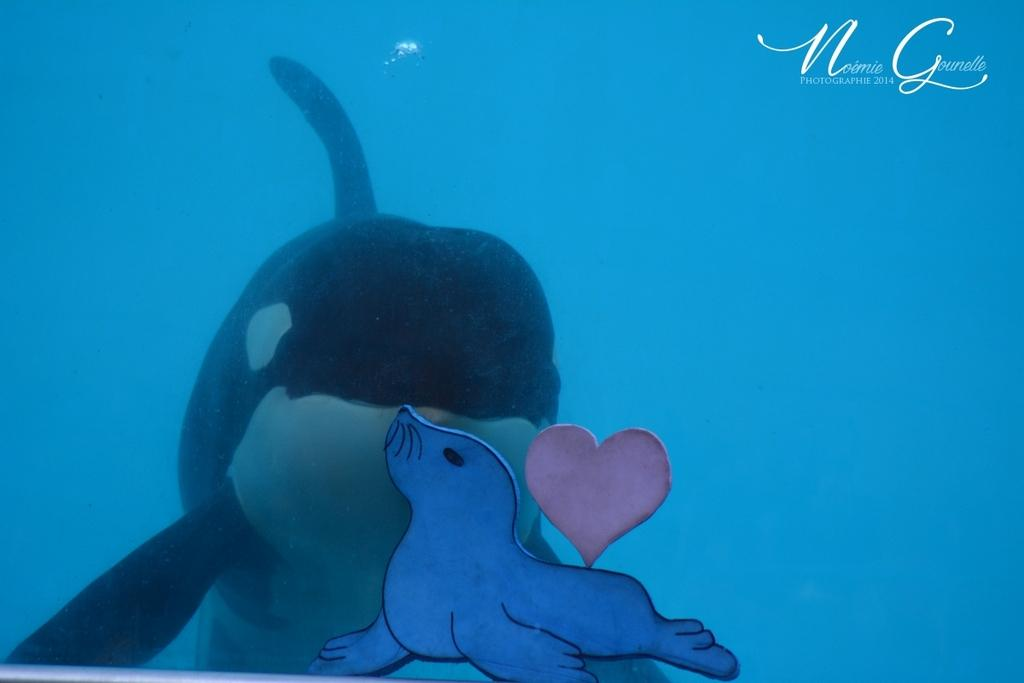What animal can be seen in the water in the image? There is a dolphin in the water in the image. What color is the water in the image? The water is blue in the image. What type of object is made of paper and visible in the image? There is a toy made of paper in the image. Can you see any flames near the dolphin in the image? No, there are no flames present in the image. What type of snails can be seen crawling on the toy made of paper in the image? There are no snails present in the image; it features a dolphin in the water and a toy made of paper. 